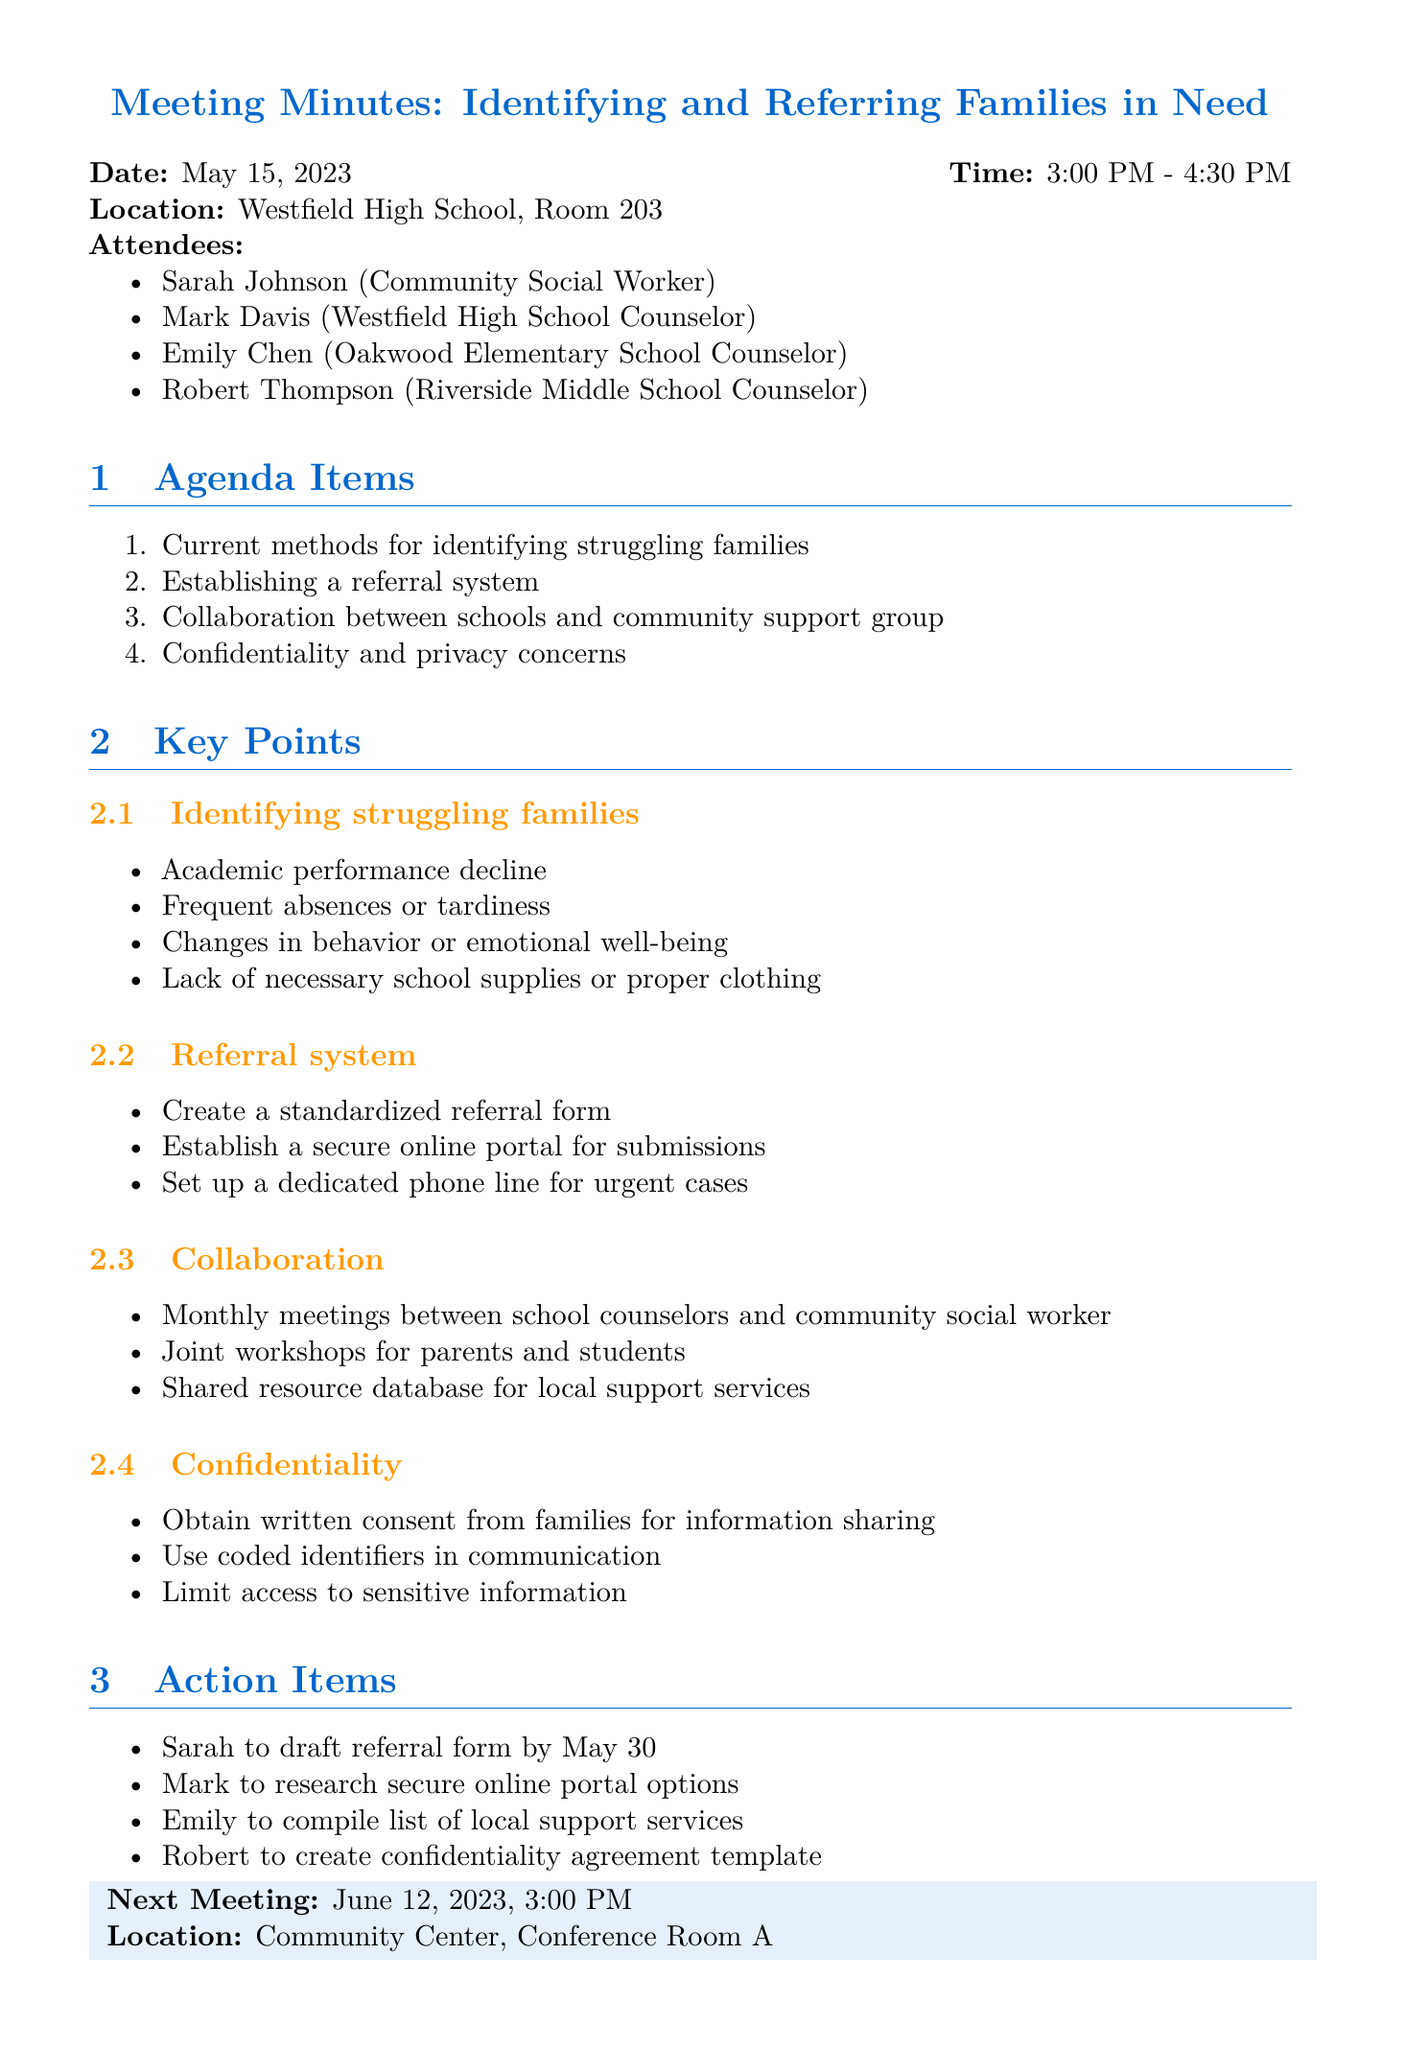What is the date of the meeting? The date of the meeting is mentioned in the document.
Answer: May 15, 2023 Who is the community social worker attending the meeting? The attendees include specific names and their roles, identifying Sarah Johnson as the community social worker.
Answer: Sarah Johnson What time does the next meeting start? The time for the next meeting is given explicitly in the document.
Answer: 3:00 PM What is one method to identify struggling families listed in the document? The document lists key points under the topic of identifying struggling families with specific methods.
Answer: Academic performance decline What is one action item assigned to Mark? The action items specify tasks assigned to different individuals, including Mark.
Answer: Research secure online portal options How often will meetings between school counselors and the community social worker occur? The document states the frequency of collaboration efforts.
Answer: Monthly What is one concern discussed regarding confidentiality? The document outlines key points regarding confidentiality and privacy concerns that were addressed in the meeting.
Answer: Obtain written consent What is the location of the next meeting? The next meeting's location is provided in the document.
Answer: Community Center, Conference Room A 